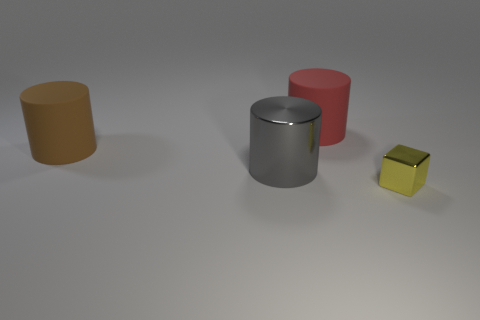Subtract all big rubber cylinders. How many cylinders are left? 1 Subtract all brown cylinders. How many cylinders are left? 2 Add 4 brown objects. How many objects exist? 8 Subtract all blocks. How many objects are left? 3 Subtract 1 cylinders. How many cylinders are left? 2 Subtract all large gray things. Subtract all yellow metallic things. How many objects are left? 2 Add 2 brown rubber things. How many brown rubber things are left? 3 Add 4 small brown rubber spheres. How many small brown rubber spheres exist? 4 Subtract 0 purple cylinders. How many objects are left? 4 Subtract all brown cylinders. Subtract all gray blocks. How many cylinders are left? 2 